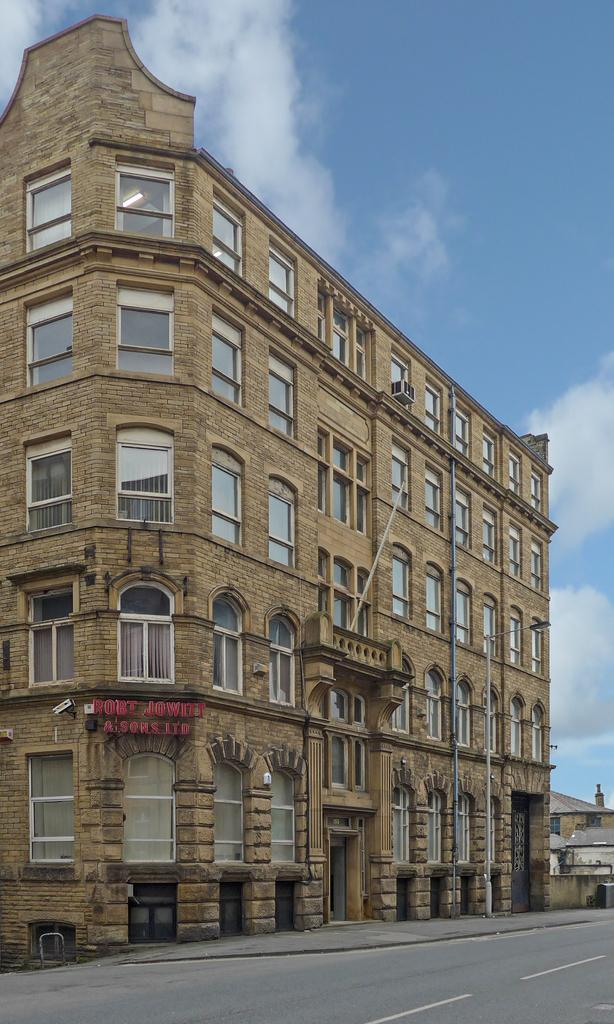What type of structures can be seen in the image? There are buildings in the image. What can be seen in the background of the image? The sky is visible in the background of the image. What markings are present on the road in the image? There are white lines on the road in the image. What type of apparel is the harbor wearing in the image? There is no harbor present in the image, and therefore no apparel can be associated with it. 